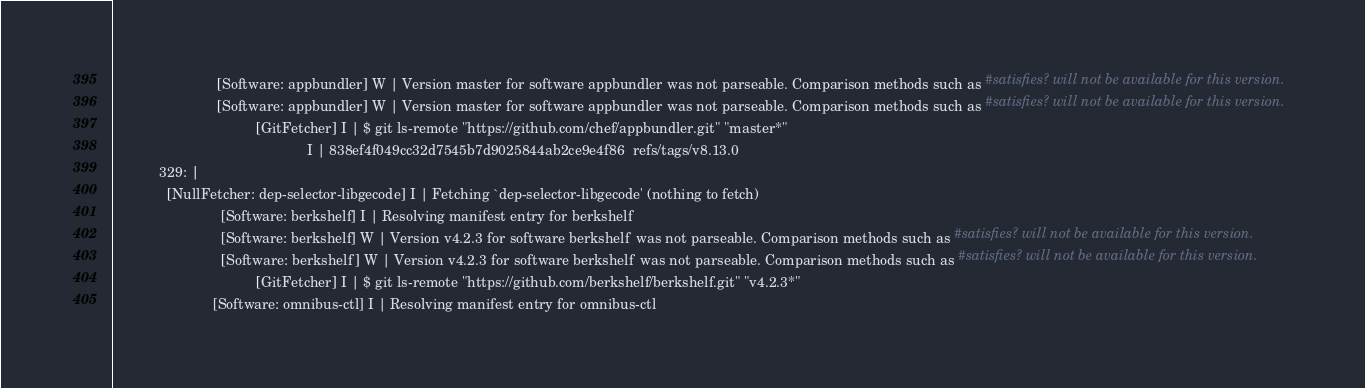<code> <loc_0><loc_0><loc_500><loc_500><_YAML_>                           [Software: appbundler] W | Version master for software appbundler was not parseable. Comparison methods such as #satisfies? will not be available for this version.
                           [Software: appbundler] W | Version master for software appbundler was not parseable. Comparison methods such as #satisfies? will not be available for this version.
                                     [GitFetcher] I | $ git ls-remote "https://github.com/chef/appbundler.git" "master*"
                                                  I | 838ef4f049cc32d7545b7d9025844ab2ce9e4f86  refs/tags/v8.13.0
            329: |
              [NullFetcher: dep-selector-libgecode] I | Fetching `dep-selector-libgecode' (nothing to fetch)
                            [Software: berkshelf] I | Resolving manifest entry for berkshelf
                            [Software: berkshelf] W | Version v4.2.3 for software berkshelf was not parseable. Comparison methods such as #satisfies? will not be available for this version.
                            [Software: berkshelf] W | Version v4.2.3 for software berkshelf was not parseable. Comparison methods such as #satisfies? will not be available for this version.
                                     [GitFetcher] I | $ git ls-remote "https://github.com/berkshelf/berkshelf.git" "v4.2.3*"
                          [Software: omnibus-ctl] I | Resolving manifest entry for omnibus-ctl</code> 